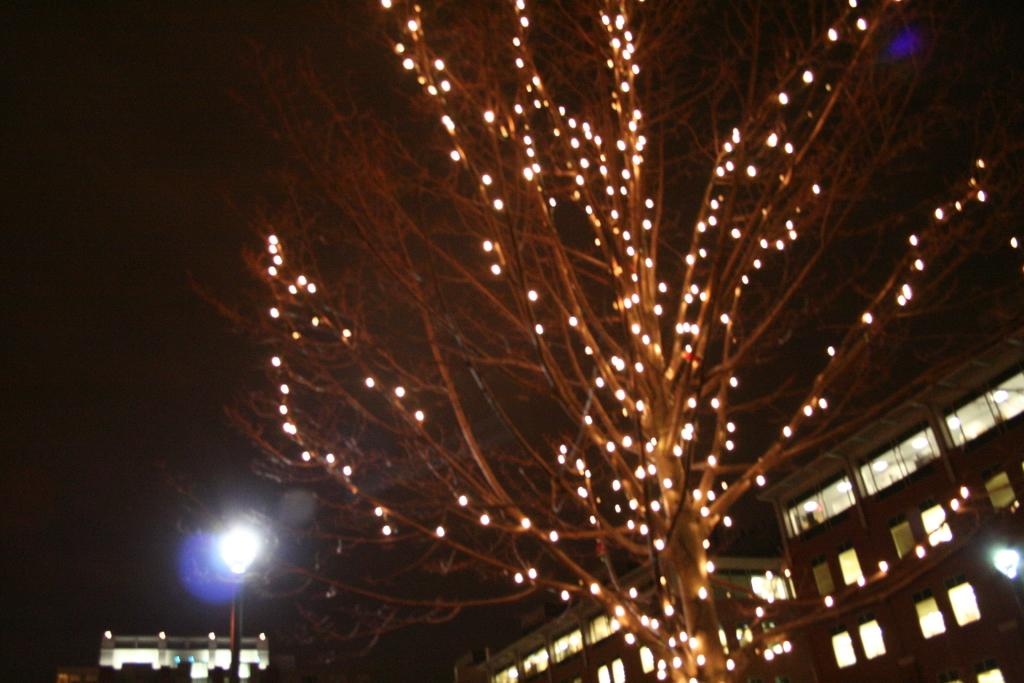What type of structures can be seen in the image? There are buildings in the image. What is the tree in the image decorated with? The tree in the image has lights on it. What can be seen on either side of the tree? There are light poles on either side of the tree. How would you describe the overall lighting in the image? The background of the image appears dark. What type of sack is hanging from the tree in the image? There is no sack hanging from the tree in the image; it is decorated with lights. 